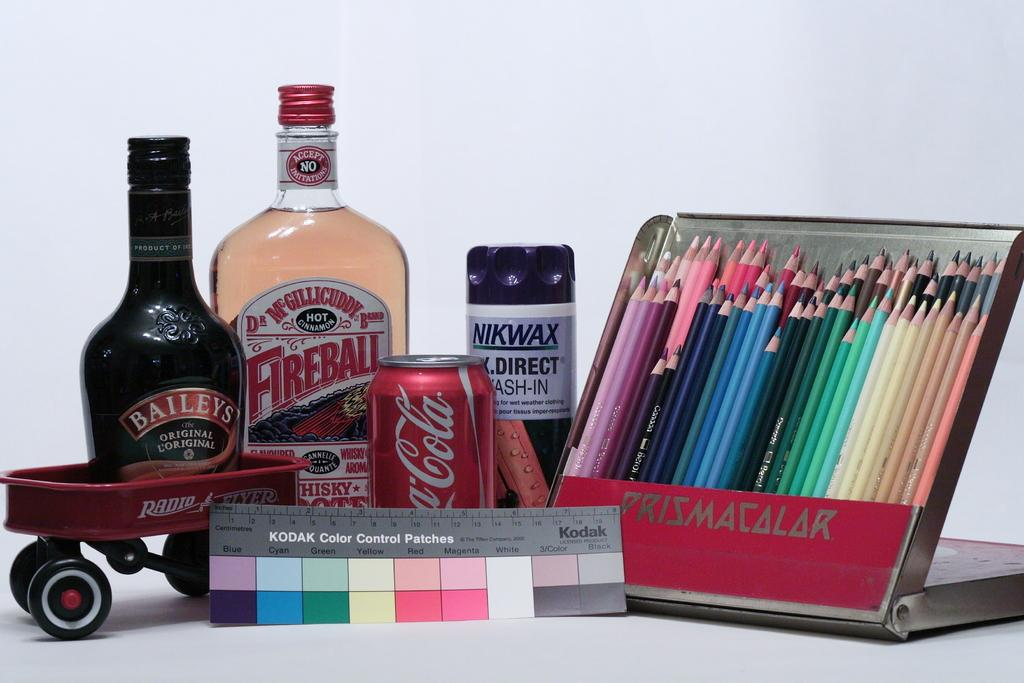<image>
Relay a brief, clear account of the picture shown. Red Coca Cola can between a Fireball and Nikiwax. 